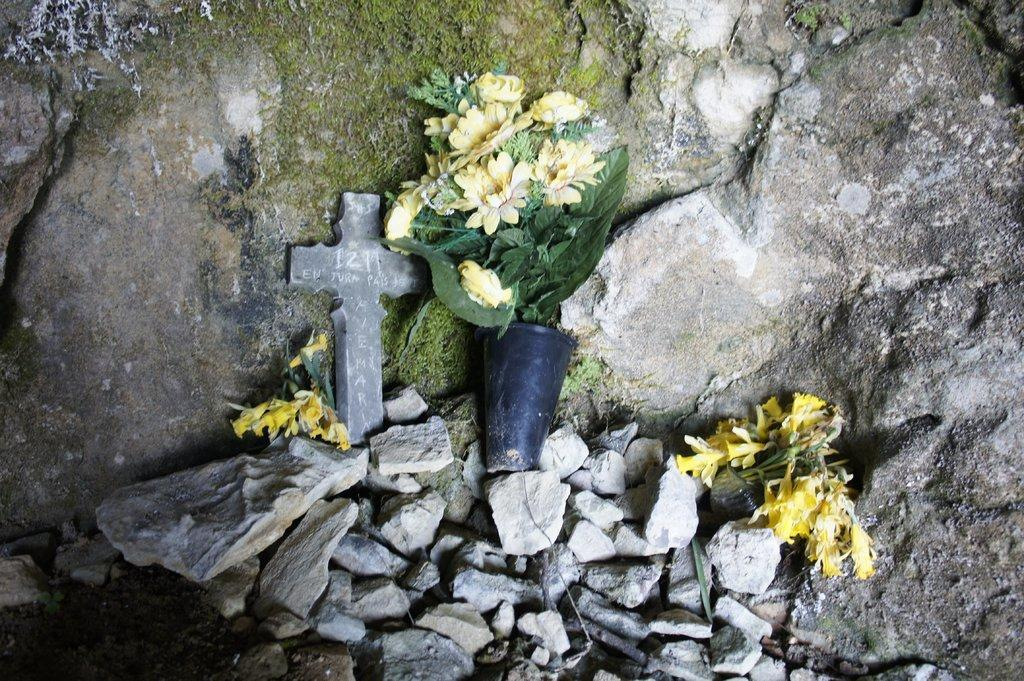What type of objects can be seen on the ground in the image? There are stones in the image. What is placed on the stones? There is a cross on the stones. What type of plants are present in the image? There are flowers in the image. Can you describe the arrangement of the flowers in the image? There is a vase with flowers and leaves in the image. What can be seen in the background of the image? There is a rock wall in the background of the image. What color is the fire burning in the image? There is no fire present in the image. What type of structure is visible in the image? The image does not show any specific structure; it primarily features stones, a cross, flowers, and a vase. 